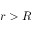Convert formula to latex. <formula><loc_0><loc_0><loc_500><loc_500>r > R</formula> 